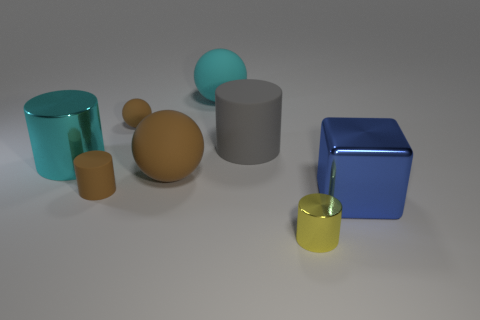Is there a matte thing of the same shape as the yellow metal thing?
Provide a succinct answer. Yes. Is the size of the matte cylinder that is in front of the cyan cylinder the same as the object that is in front of the large shiny cube?
Give a very brief answer. Yes. Are there more cyan rubber objects than tiny purple metal objects?
Offer a terse response. Yes. How many brown spheres have the same material as the tiny brown cylinder?
Ensure brevity in your answer.  2. Do the gray thing and the tiny yellow shiny object have the same shape?
Your answer should be very brief. Yes. There is a object in front of the large blue block that is to the right of the large gray object that is behind the brown rubber cylinder; what is its size?
Provide a short and direct response. Small. There is a matte cylinder on the left side of the big gray cylinder; are there any tiny brown objects right of it?
Your response must be concise. Yes. How many large rubber things are behind the object that is in front of the big metal object that is right of the tiny brown cylinder?
Offer a terse response. 3. What color is the thing that is in front of the large brown rubber ball and left of the small yellow cylinder?
Your answer should be very brief. Brown. What number of big things are the same color as the big metal cylinder?
Your answer should be compact. 1. 